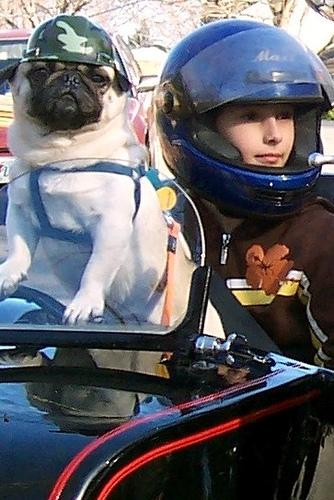Discuss the presence of any accessories or additional objects in the image. Various accessories and objects in the image include a silver zipper on a sweater, an orange leash, stripes on the sweater, a part of the dog's harness, and a small red car that is visible. Identify the colors of the various objects found in the image. Vehicle: bright black. Mention the main objects in the image and their primary interactions. The main objects are the young girl wearing a blue helmet and a brown jacket, and the small white dog wearing a hat and holding onto the steering wheel. They appear to be in a vehicle with a red stripe. Describe the scene and background surroundings in the image. The primary scene takes place inside a vehicle with a windshield, a red stripe, and bright black color. There are bright trees in the background, and some concrete is visible. What is the pattern on the dog's hat? The dog's hat has a camouflage pattern. Provide a brief description of the image focusing on the girl and the dog. A young girl in a blue helmet and brown jacket with white and yellow stripes is accompanied by a small white dog wearing a camouflage hat and holding a steering wheel with his paws. Analyze the sentiment expressed in the image. The sentiment in the image seems to be cheerful and lighthearted, as a young girl and a dog are engaging in a fun and unique activity together. Describe the facial features of the dog in the image. The dog has black eyes, a droopy mouth, a black nose, and a light grey coat. Count the number of distinct objects mentioned in the image with their respective colors. 8 objects - blue helmet, brown jacket with white and yellow stripes, light brown orangish flower, red car stripe, camouflage hat, clear visor, bright black vehicle, small white dog. Examine the quality of the photo taken by Jackson Mingus. The quality of the photo is difficult to assess without actually seeing the image, but there are many details and objects described with accurate bounding box information, indicating good overall quality. Look for the mysterious orange cat hiding behind the dog. No, it's not mentioned in the image. 